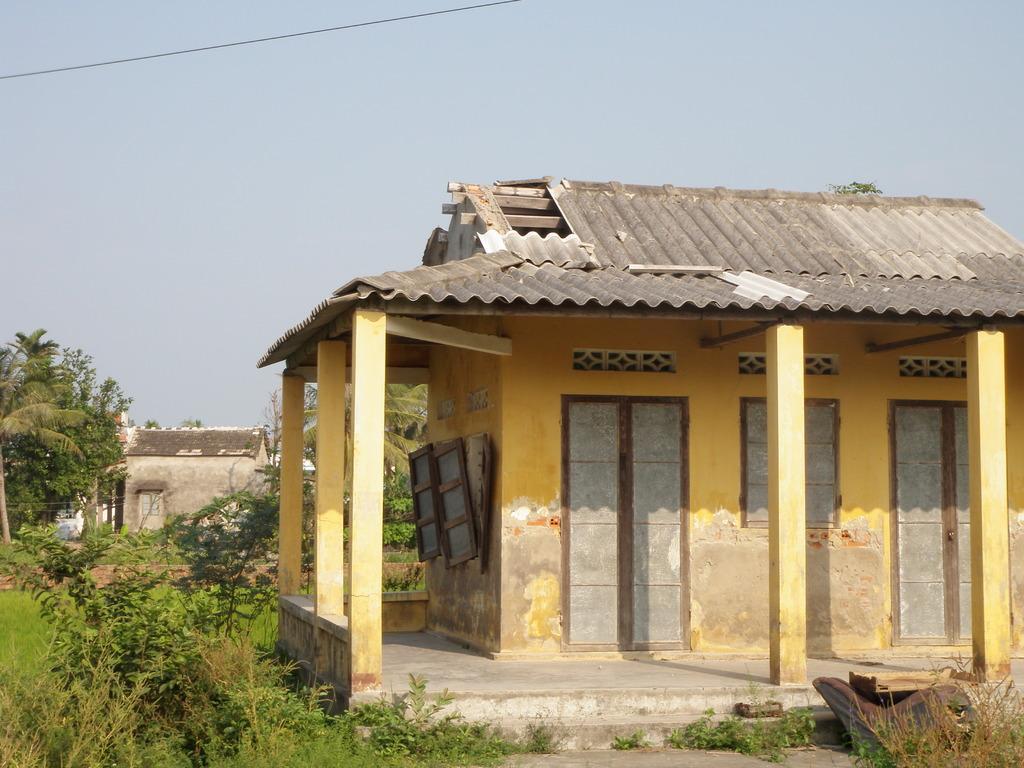How would you summarize this image in a sentence or two? Here in this picture we can see a house present on the ground over there and we can see doors and windows and pillars of it over there and on the ground we can see grass, plants and trees present over there and in the far also we can see a house present over there and we can see the sky is cloudy over there. 